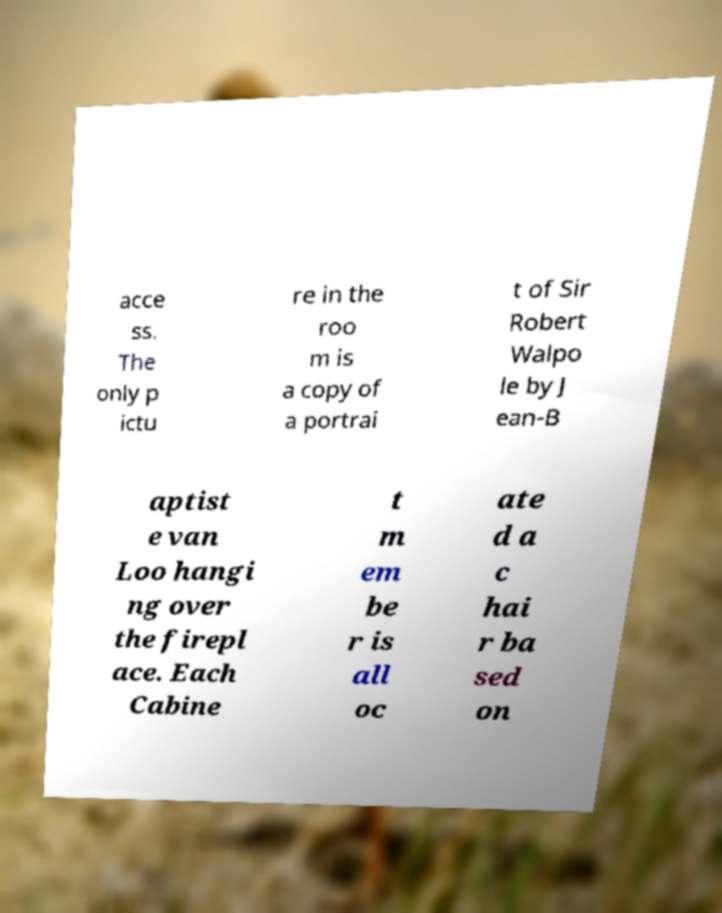For documentation purposes, I need the text within this image transcribed. Could you provide that? acce ss. The only p ictu re in the roo m is a copy of a portrai t of Sir Robert Walpo le by J ean-B aptist e van Loo hangi ng over the firepl ace. Each Cabine t m em be r is all oc ate d a c hai r ba sed on 